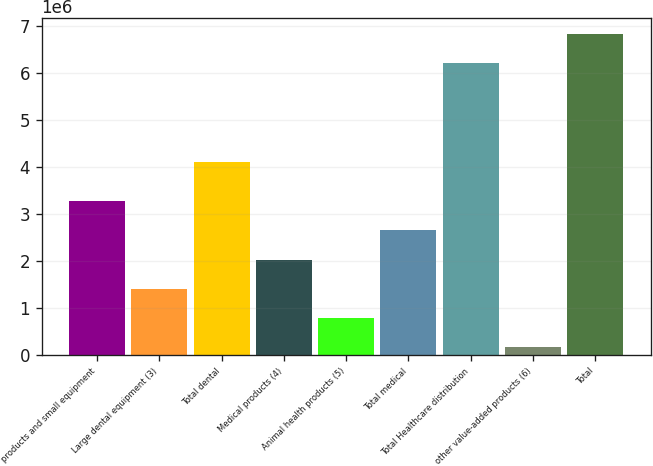Convert chart to OTSL. <chart><loc_0><loc_0><loc_500><loc_500><bar_chart><fcel>products and small equipment<fcel>Large dental equipment (3)<fcel>Total dental<fcel>Medical products (4)<fcel>Animal health products (5)<fcel>Total medical<fcel>Total Healthcare distribution<fcel>other value-added products (6)<fcel>Total<nl><fcel>3.27185e+06<fcel>1.40671e+06<fcel>4.1066e+06<fcel>2.02843e+06<fcel>785001<fcel>2.65014e+06<fcel>6.21712e+06<fcel>163289<fcel>6.83884e+06<nl></chart> 